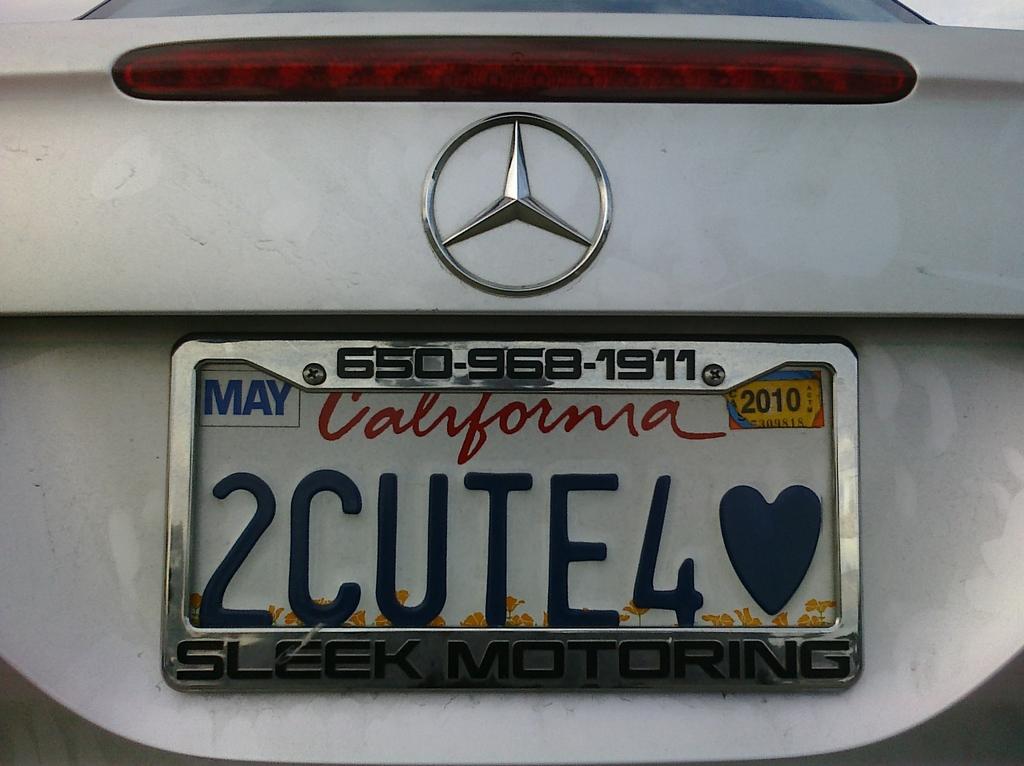What is the licence number?
Give a very brief answer. 2cute4. 